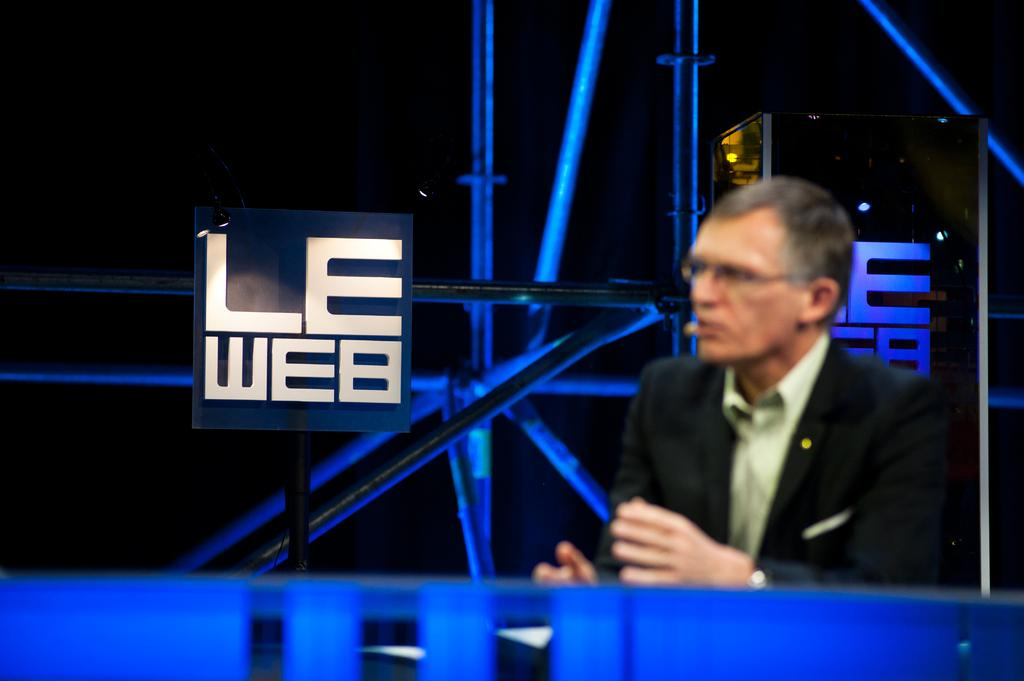<image>
Summarize the visual content of the image. Man is having a speech on the LE web. 